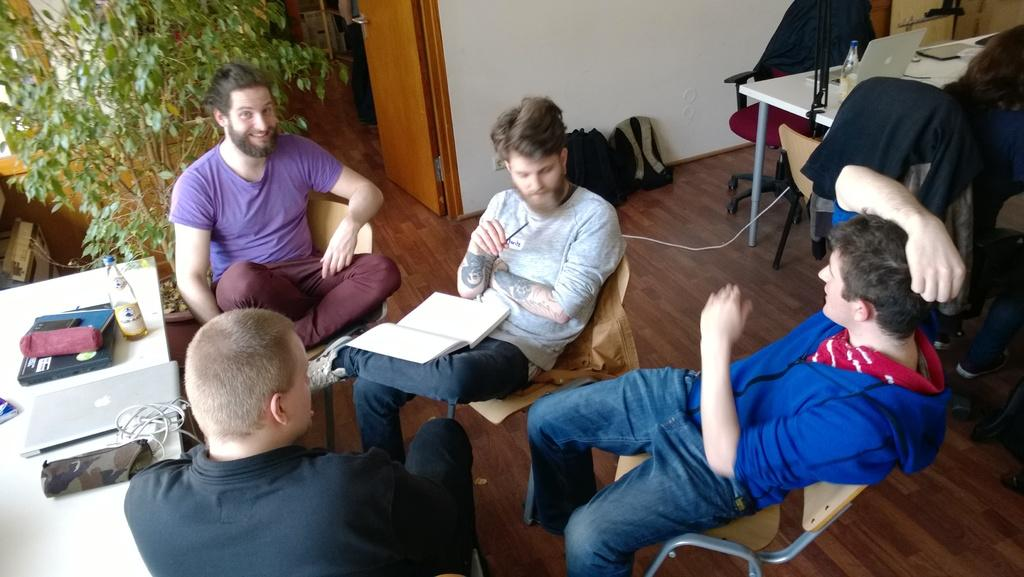Where was the image taken? The image was taken indoors. What type of furniture is visible in the image? There are tables and chairs in the image. Can you describe the plant in the image? There is a plant on the left side of the image. What are the people in the image doing? People are sitting on the chairs. What electronic device is on the table? There is a laptop on the table. What other objects are on the table? There is a bottle and a book on the table. What type of jail is visible in the image? There is no jail present in the image. Can you describe the heart-shaped object on the table? There is no heart-shaped object present in the image. 